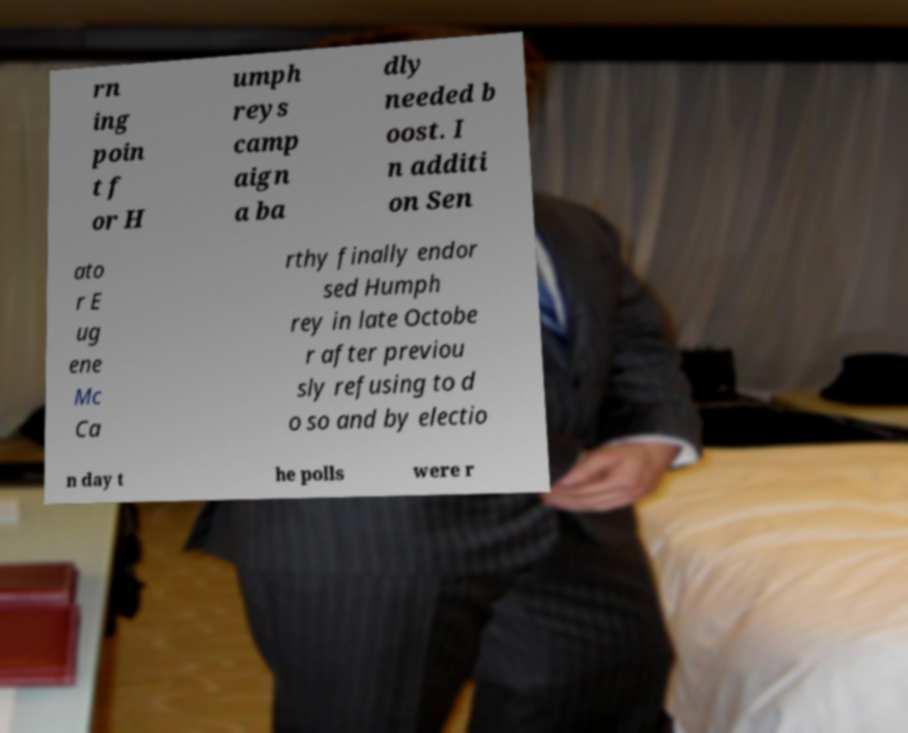Could you extract and type out the text from this image? rn ing poin t f or H umph reys camp aign a ba dly needed b oost. I n additi on Sen ato r E ug ene Mc Ca rthy finally endor sed Humph rey in late Octobe r after previou sly refusing to d o so and by electio n day t he polls were r 